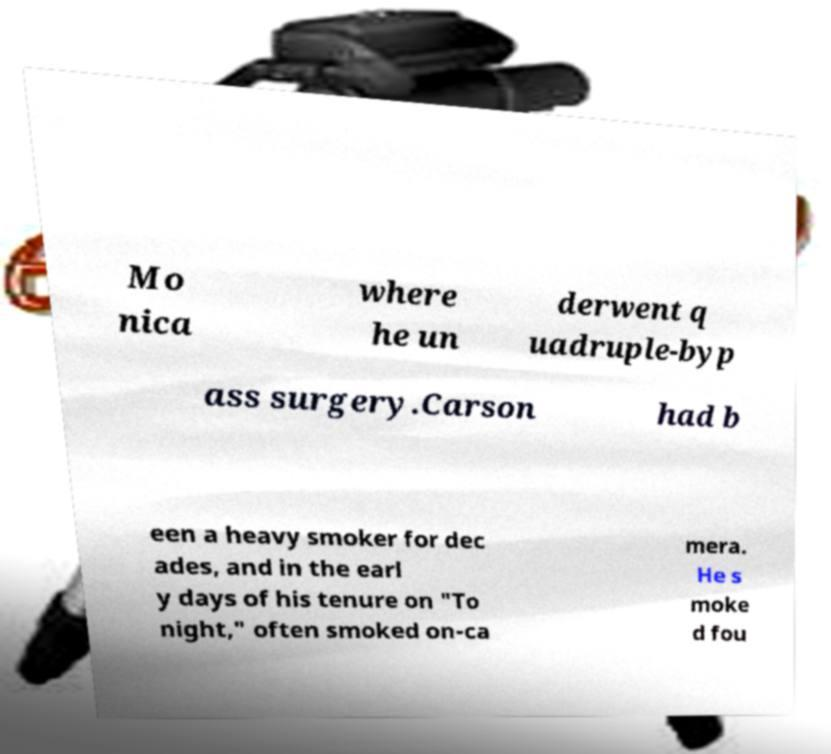What messages or text are displayed in this image? I need them in a readable, typed format. Mo nica where he un derwent q uadruple-byp ass surgery.Carson had b een a heavy smoker for dec ades, and in the earl y days of his tenure on "To night," often smoked on-ca mera. He s moke d fou 